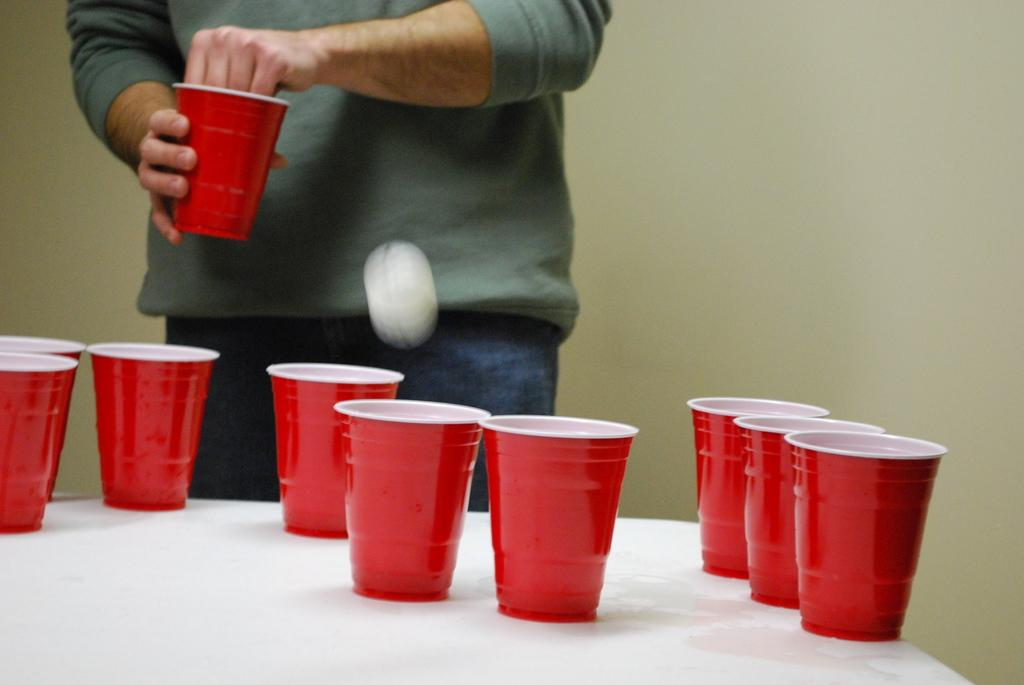What objects are on the table in the image? There are plastic cups on a table in the image. What is the person in front of the table doing? The person is standing in front of the table and holding a cup in his hand. Is there anything else in the air besides the person and the table? Yes, there is a ball in the air. Where is the parcel located in the image? There is no parcel present in the image. What type of jail can be seen in the background of the image? There is no jail present in the image. 